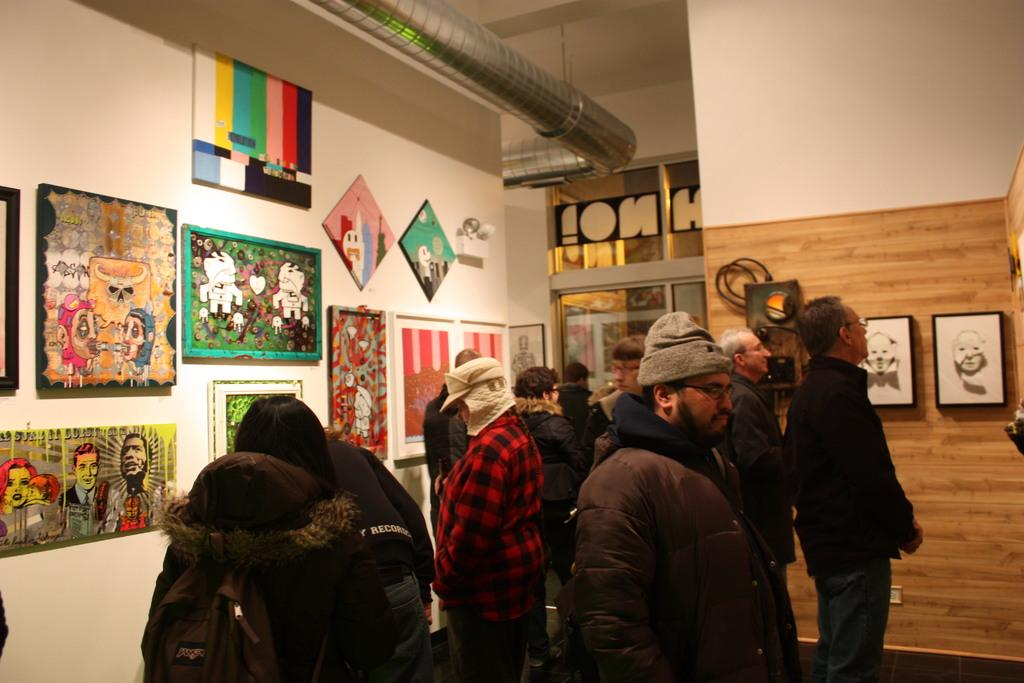What can be seen in the room in the image? There are people in the room. What is attached to the wall in the image? There are frames attached to the wall. What is attached to the roof in the image? There is a steel pipe attached to the roof. What type of door is present in the room? There is a glass door in the room. How many pickles are on the table in the image? There is no table or pickles present in the image. What is the distribution of the frames on the wall in the image? The distribution of the frames on the wall cannot be determined from the image, as only their presence is mentioned. 